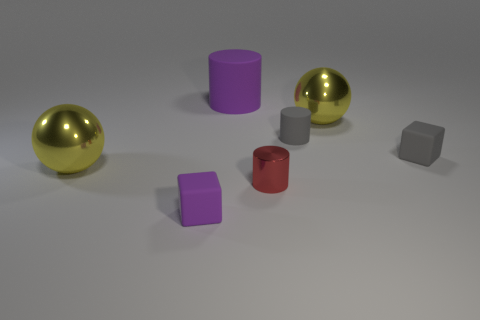Are there any matte cubes that have the same color as the big rubber object?
Your answer should be very brief. Yes. Is the color of the tiny object that is on the left side of the red metal object the same as the large rubber thing?
Your answer should be very brief. Yes. How many other red things are the same shape as the small metallic thing?
Your answer should be very brief. 0. The other block that is made of the same material as the tiny purple block is what size?
Keep it short and to the point. Small. Is the number of purple objects behind the large purple matte object the same as the number of tiny gray shiny objects?
Your response must be concise. Yes. Is the large matte cylinder the same color as the shiny cylinder?
Offer a very short reply. No. Does the large yellow shiny thing in front of the small gray rubber block have the same shape as the gray matte thing that is in front of the tiny gray rubber cylinder?
Ensure brevity in your answer.  No. What material is the small red thing that is the same shape as the big purple object?
Your response must be concise. Metal. There is a object that is both on the right side of the big rubber cylinder and on the left side of the gray rubber cylinder; what is its color?
Ensure brevity in your answer.  Red. There is a cylinder in front of the sphere on the left side of the purple matte cylinder; is there a red thing that is left of it?
Your answer should be very brief. No. 